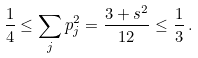<formula> <loc_0><loc_0><loc_500><loc_500>\frac { 1 } { 4 } \leq \sum _ { j } p _ { j } ^ { 2 } = \frac { 3 + s ^ { 2 } } { 1 2 } \leq \frac { 1 } { 3 } \, .</formula> 